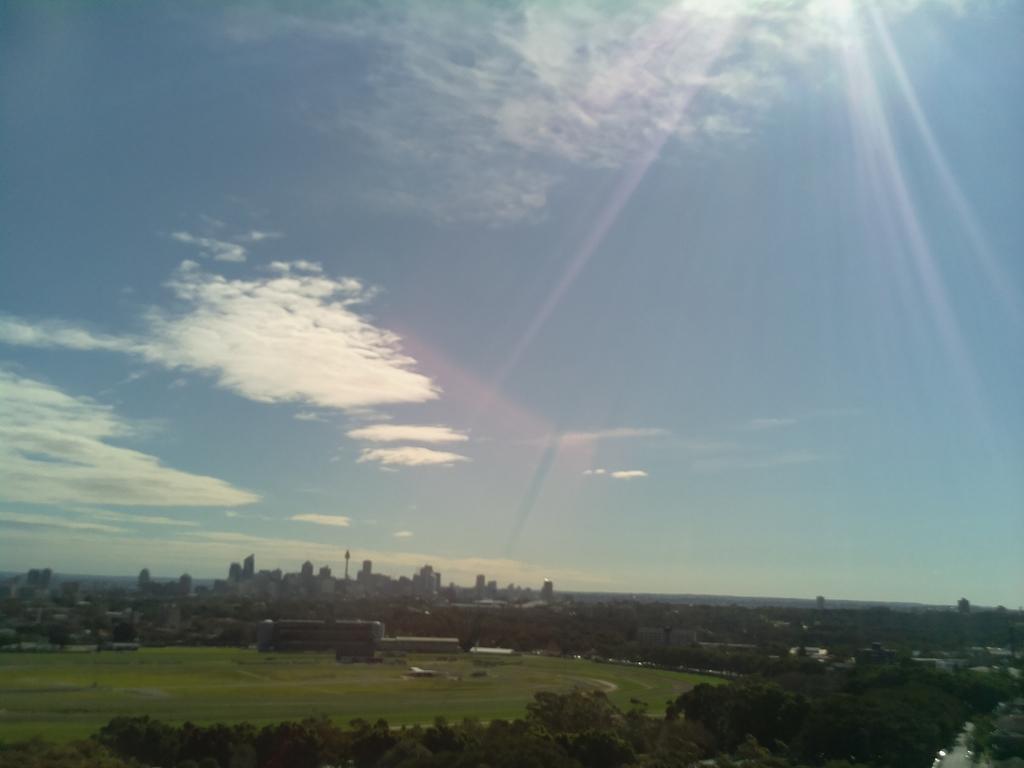Describe this image in one or two sentences. In the picture I can see trees, ground, buildings and the sky with clouds and sun rays here. 